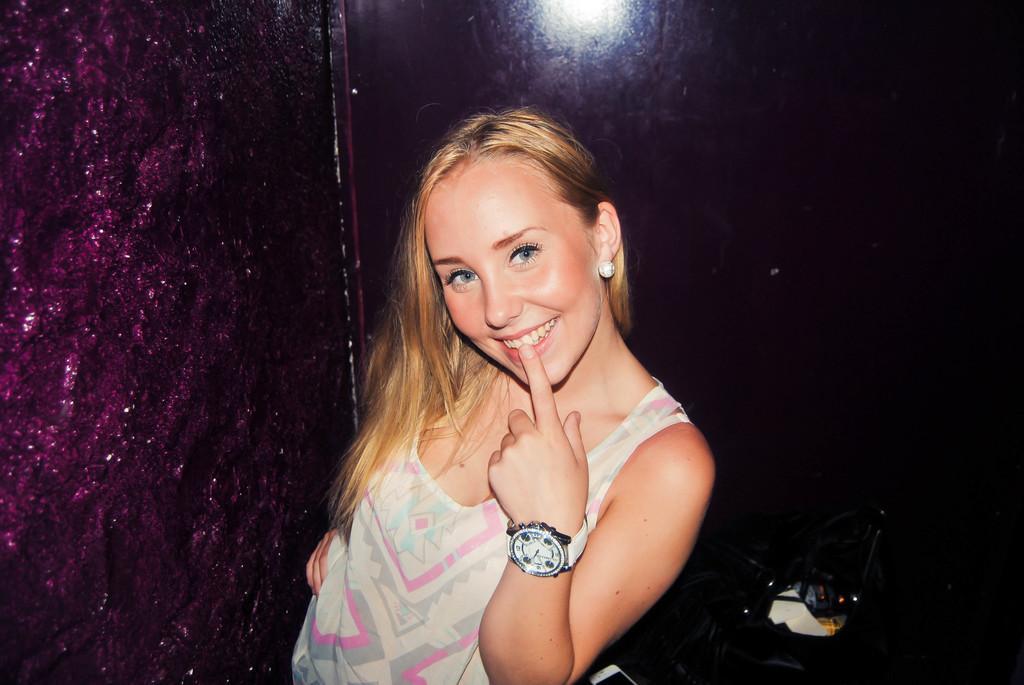In one or two sentences, can you explain what this image depicts? There is a woman in a t-shirt, wearing a watch, placing a finger on her lip, smiling and standing, near a mobile on the table and wall. The background is dark in color. 